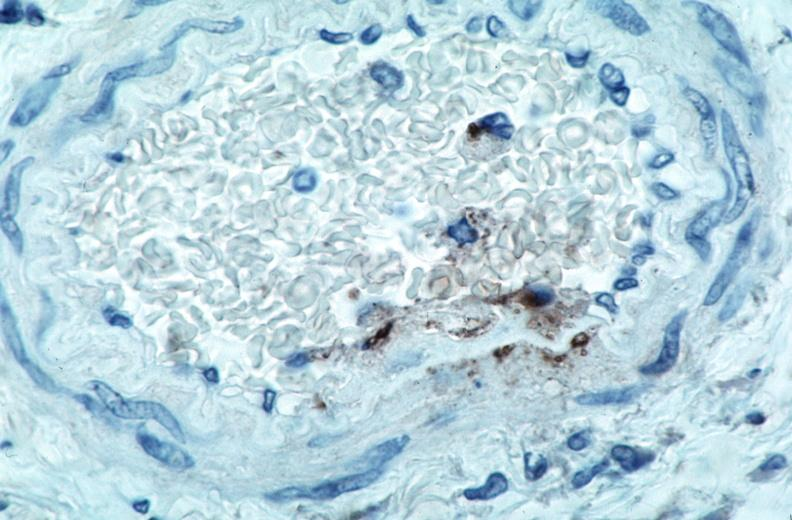s cardiovascular present?
Answer the question using a single word or phrase. Yes 